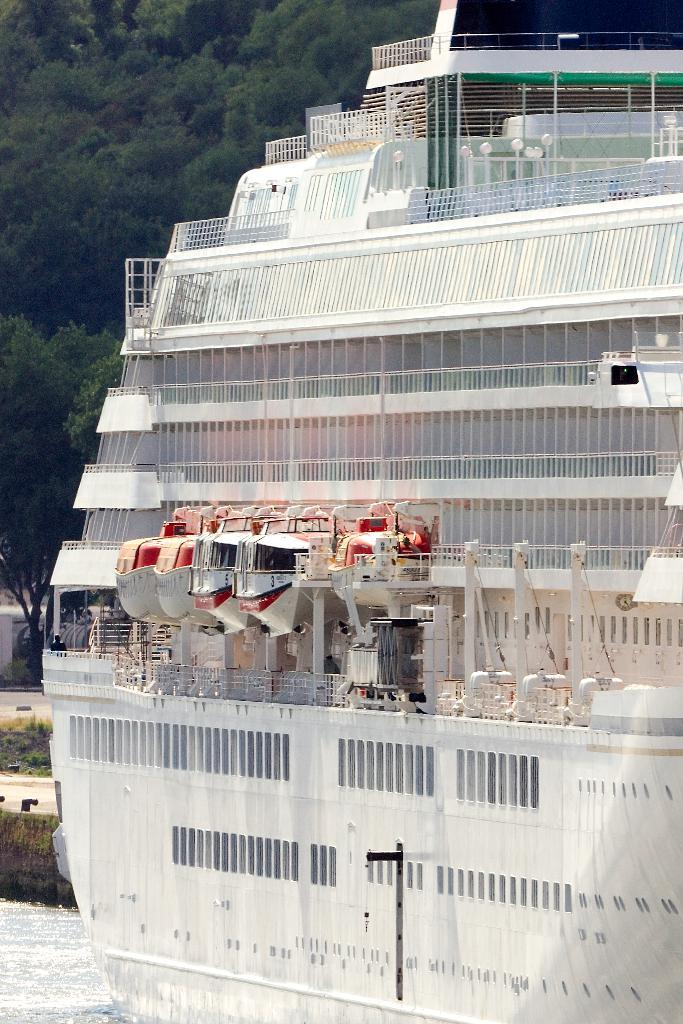What is the main subject of the image? The main subject of the image is a ship. Can you describe the color of the ship? The ship is white in color. What can be seen in the background of the image? There are trees in the background of the image. Is there a writer sitting on the ship in the image? There is no writer present in the image; it only features a white ship. Can you see any rats on the ship in the image? There are no rats visible on the ship in the image. 